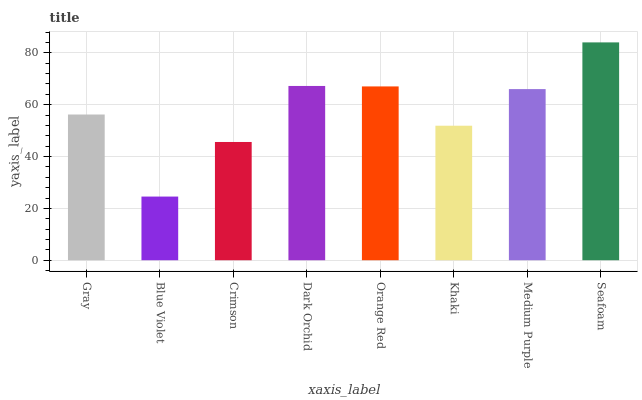Is Blue Violet the minimum?
Answer yes or no. Yes. Is Seafoam the maximum?
Answer yes or no. Yes. Is Crimson the minimum?
Answer yes or no. No. Is Crimson the maximum?
Answer yes or no. No. Is Crimson greater than Blue Violet?
Answer yes or no. Yes. Is Blue Violet less than Crimson?
Answer yes or no. Yes. Is Blue Violet greater than Crimson?
Answer yes or no. No. Is Crimson less than Blue Violet?
Answer yes or no. No. Is Medium Purple the high median?
Answer yes or no. Yes. Is Gray the low median?
Answer yes or no. Yes. Is Seafoam the high median?
Answer yes or no. No. Is Blue Violet the low median?
Answer yes or no. No. 